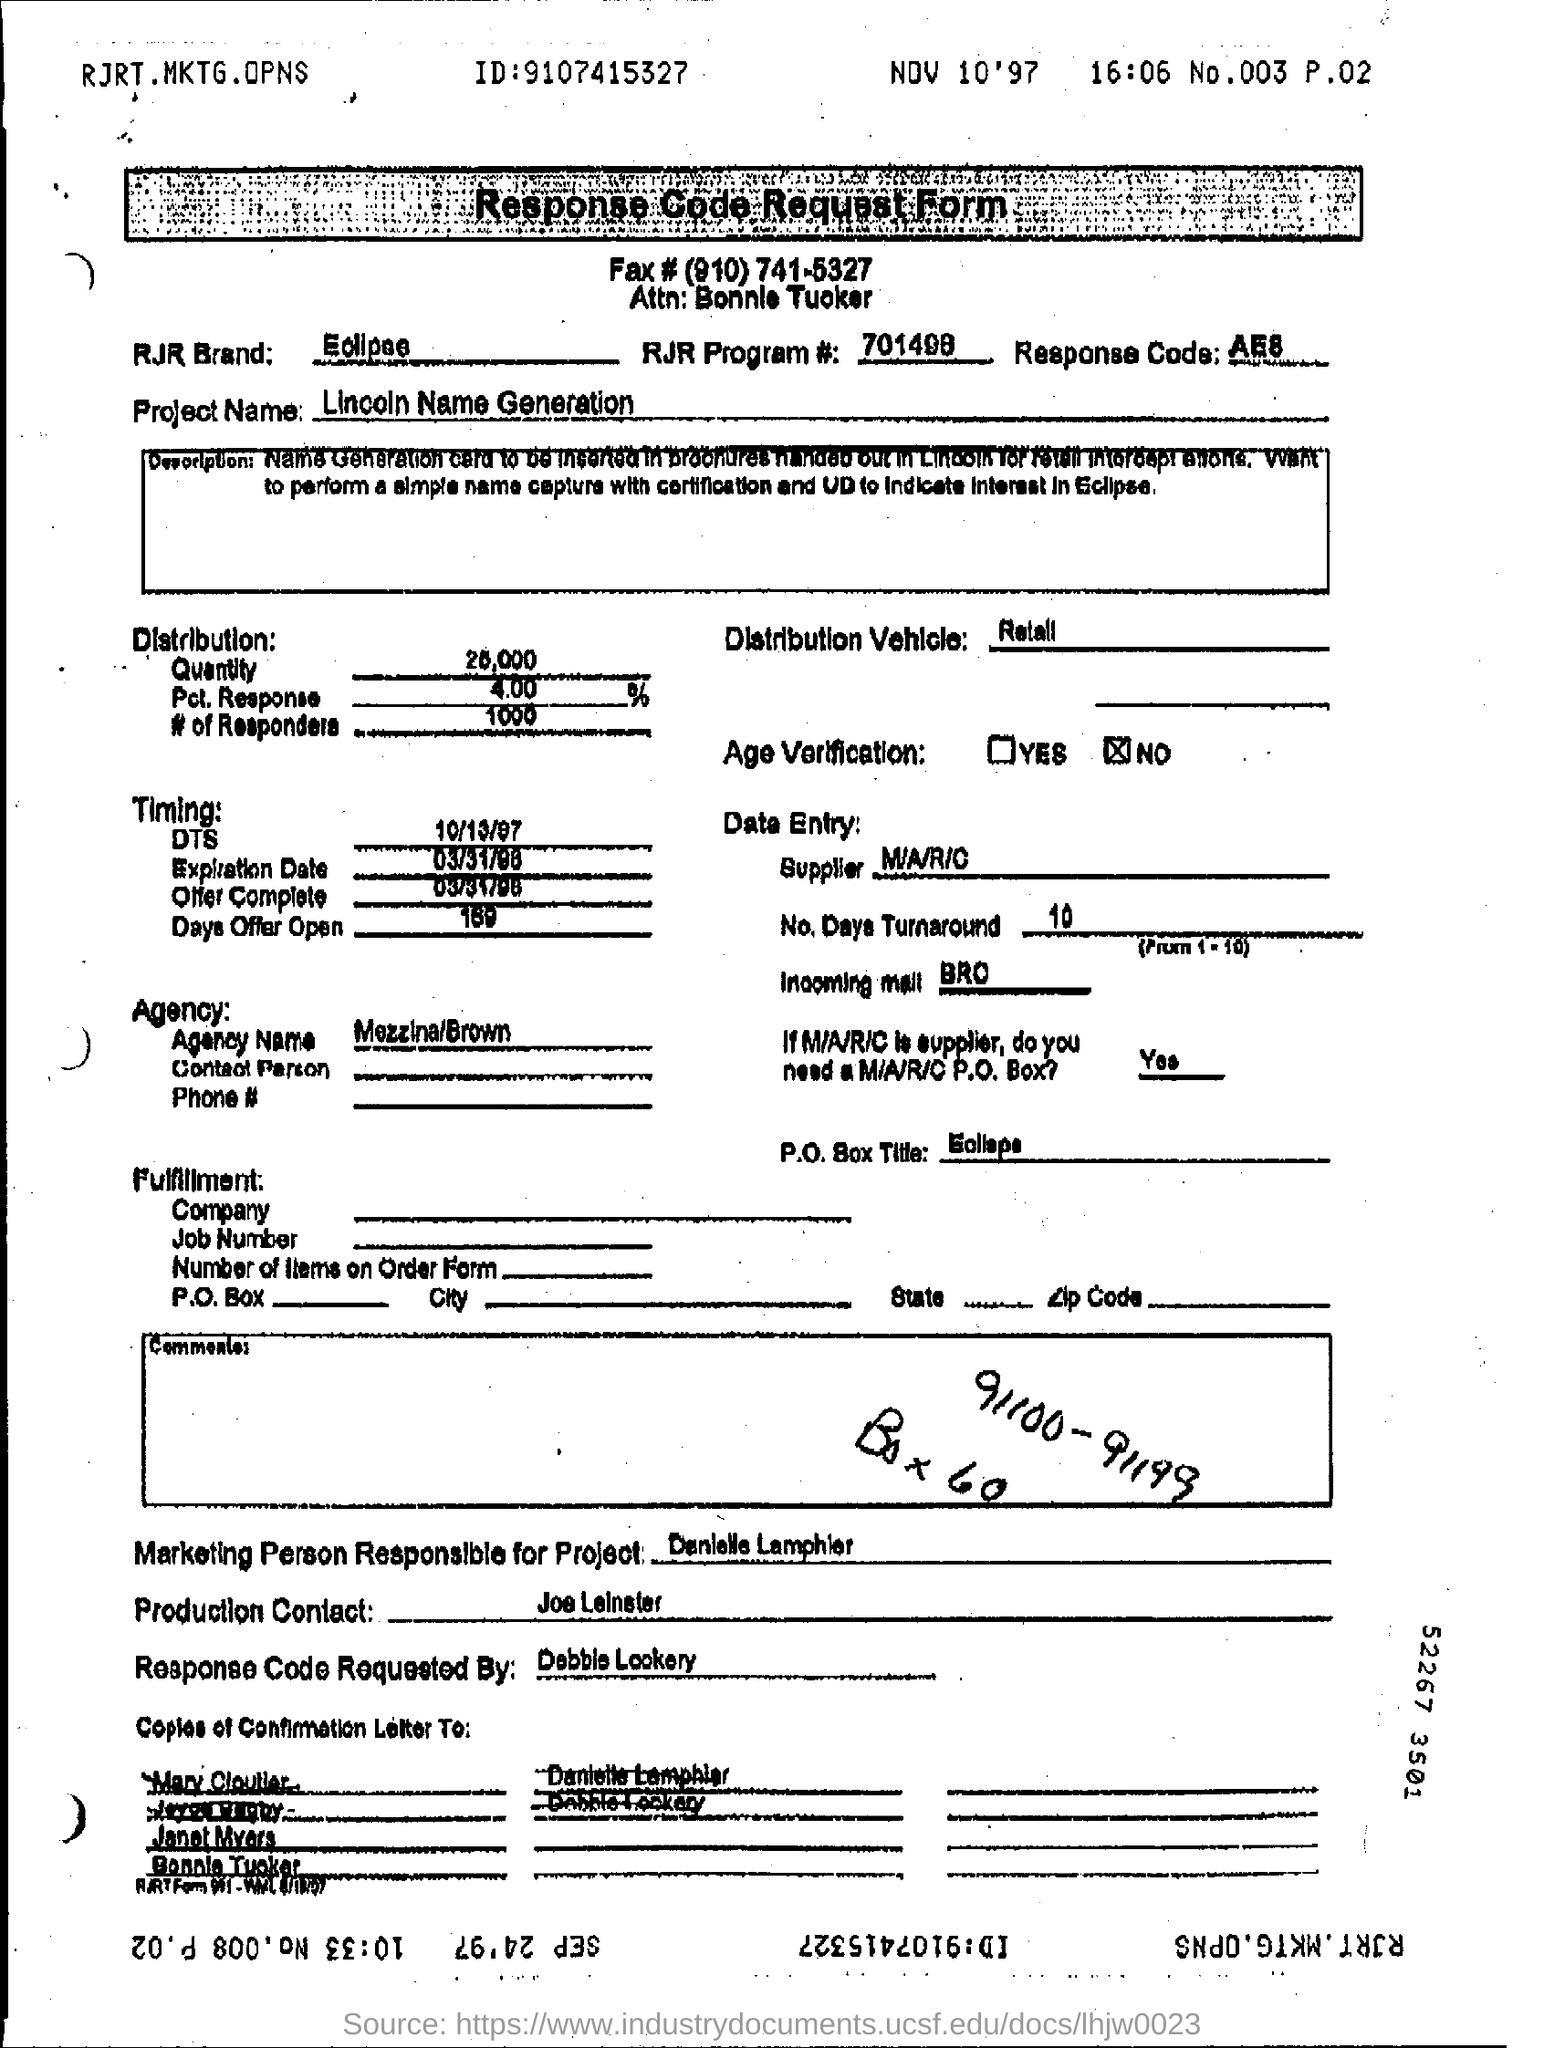What is the ID specified in the header?
Keep it short and to the point. 9107415327. 